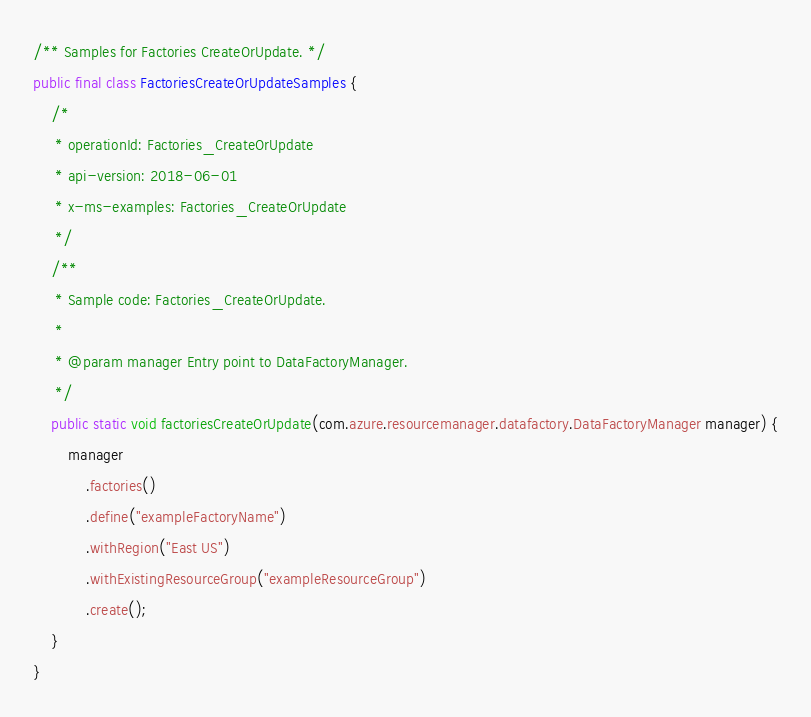<code> <loc_0><loc_0><loc_500><loc_500><_Java_>/** Samples for Factories CreateOrUpdate. */
public final class FactoriesCreateOrUpdateSamples {
    /*
     * operationId: Factories_CreateOrUpdate
     * api-version: 2018-06-01
     * x-ms-examples: Factories_CreateOrUpdate
     */
    /**
     * Sample code: Factories_CreateOrUpdate.
     *
     * @param manager Entry point to DataFactoryManager.
     */
    public static void factoriesCreateOrUpdate(com.azure.resourcemanager.datafactory.DataFactoryManager manager) {
        manager
            .factories()
            .define("exampleFactoryName")
            .withRegion("East US")
            .withExistingResourceGroup("exampleResourceGroup")
            .create();
    }
}
</code> 